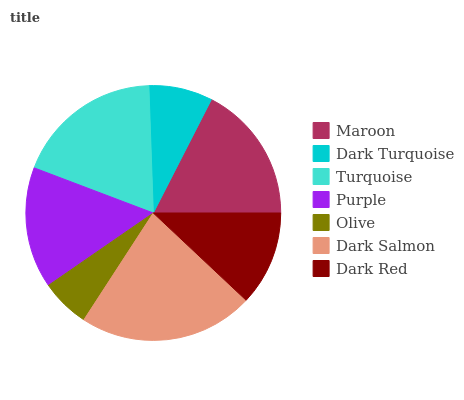Is Olive the minimum?
Answer yes or no. Yes. Is Dark Salmon the maximum?
Answer yes or no. Yes. Is Dark Turquoise the minimum?
Answer yes or no. No. Is Dark Turquoise the maximum?
Answer yes or no. No. Is Maroon greater than Dark Turquoise?
Answer yes or no. Yes. Is Dark Turquoise less than Maroon?
Answer yes or no. Yes. Is Dark Turquoise greater than Maroon?
Answer yes or no. No. Is Maroon less than Dark Turquoise?
Answer yes or no. No. Is Purple the high median?
Answer yes or no. Yes. Is Purple the low median?
Answer yes or no. Yes. Is Maroon the high median?
Answer yes or no. No. Is Olive the low median?
Answer yes or no. No. 